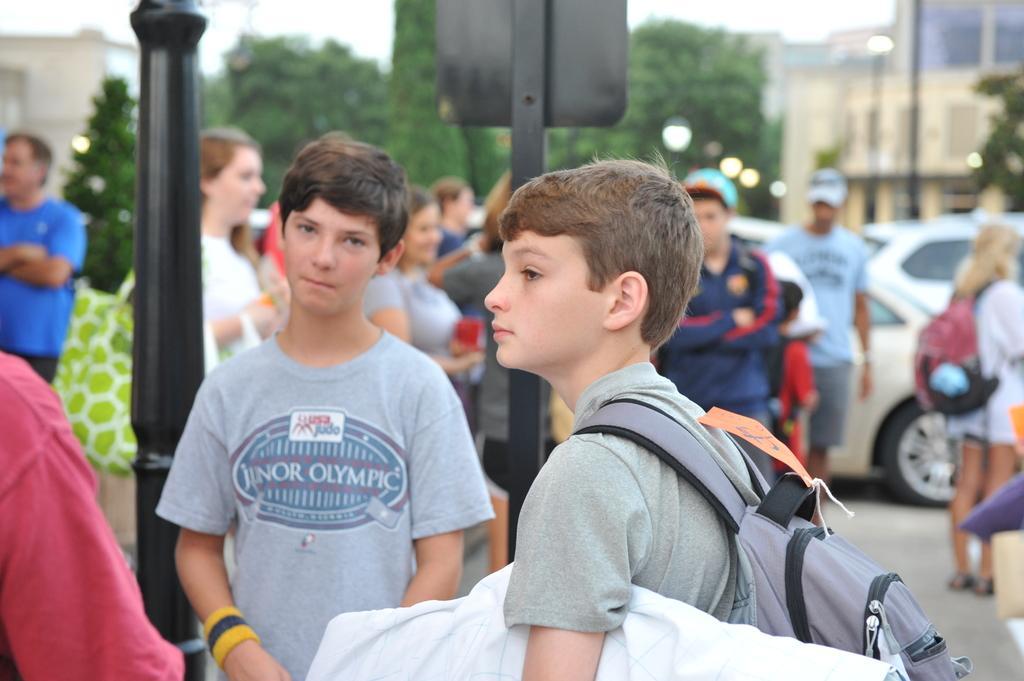Could you give a brief overview of what you see in this image? In this image I can see few people are standing. I can also see few of them are carrying bags. In the background I can see few trees, few cars, buildings and I can see this image is little bit blurry from background. 